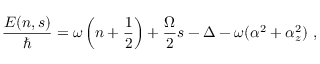<formula> <loc_0><loc_0><loc_500><loc_500>\frac { E ( n , s ) } { } = \omega \left ( n + \frac { 1 } { 2 } \right ) + \frac { \Omega } { 2 } s - \Delta - \omega ( \alpha ^ { 2 } + \alpha _ { z } ^ { 2 } ) \ ,</formula> 